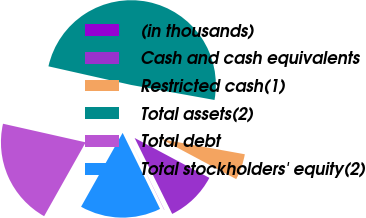Convert chart to OTSL. <chart><loc_0><loc_0><loc_500><loc_500><pie_chart><fcel>(in thousands)<fcel>Cash and cash equivalents<fcel>Restricted cash(1)<fcel>Total assets(2)<fcel>Total debt<fcel>Total stockholders' equity(2)<nl><fcel>0.03%<fcel>9.89%<fcel>4.96%<fcel>49.32%<fcel>20.37%<fcel>15.44%<nl></chart> 